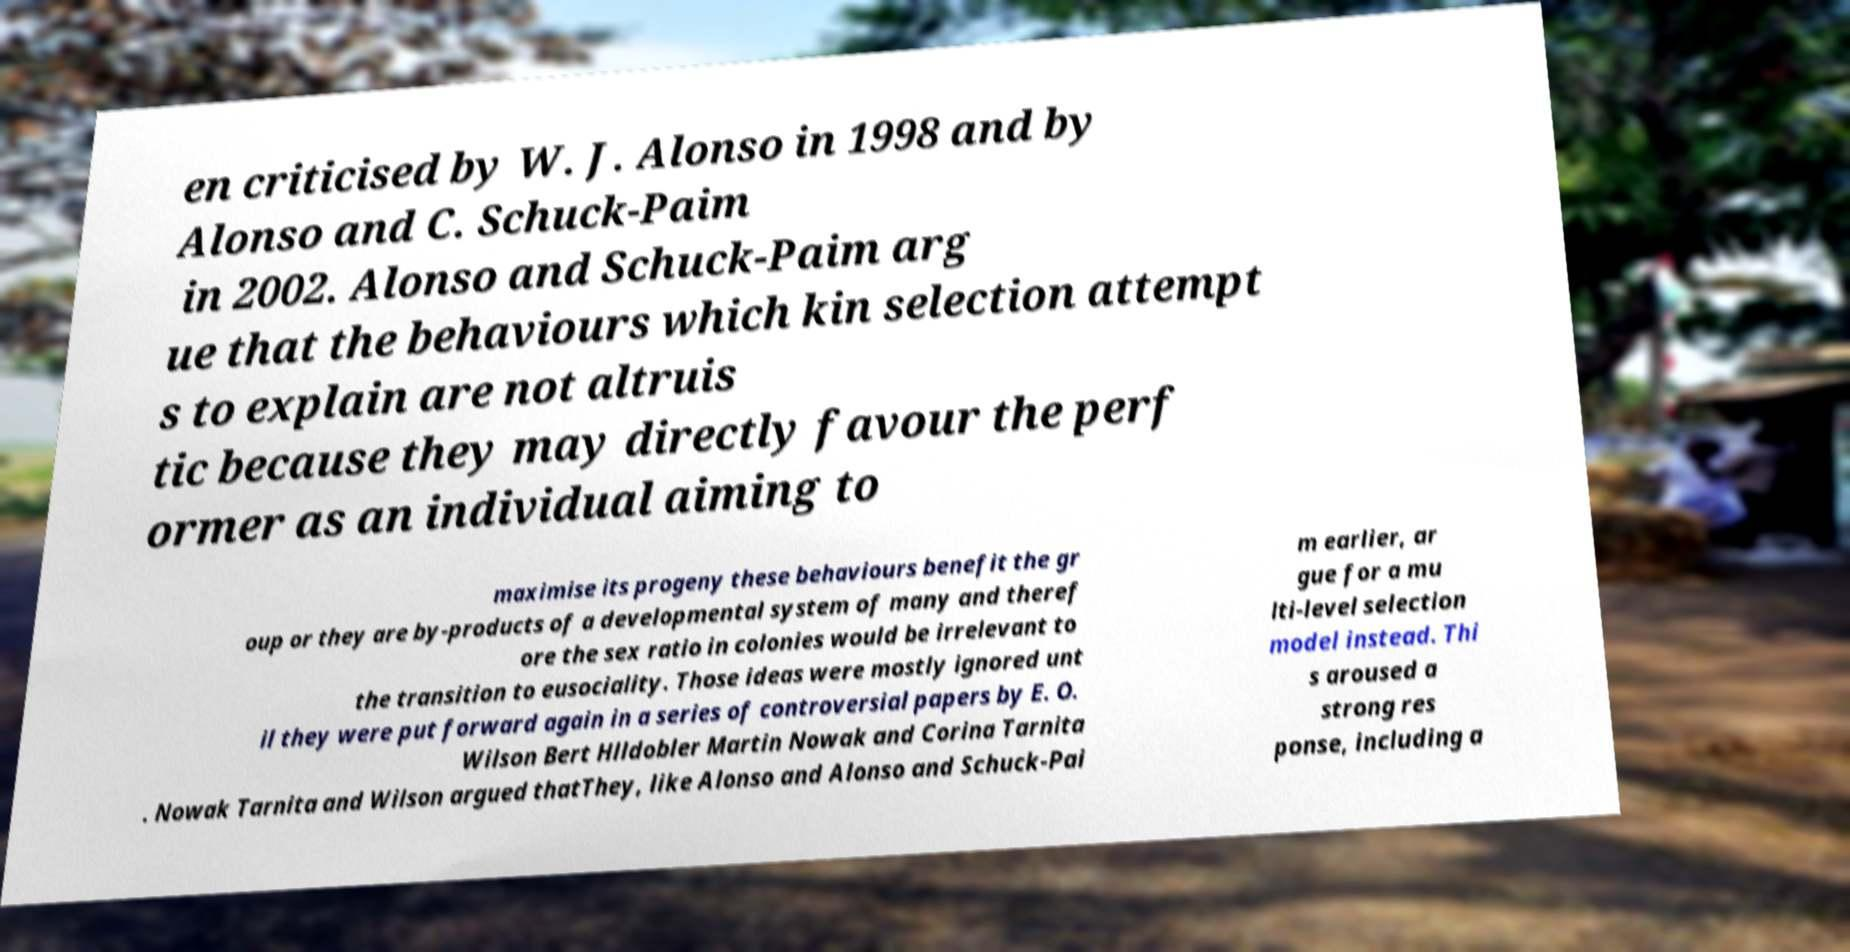What messages or text are displayed in this image? I need them in a readable, typed format. en criticised by W. J. Alonso in 1998 and by Alonso and C. Schuck-Paim in 2002. Alonso and Schuck-Paim arg ue that the behaviours which kin selection attempt s to explain are not altruis tic because they may directly favour the perf ormer as an individual aiming to maximise its progeny these behaviours benefit the gr oup or they are by-products of a developmental system of many and theref ore the sex ratio in colonies would be irrelevant to the transition to eusociality. Those ideas were mostly ignored unt il they were put forward again in a series of controversial papers by E. O. Wilson Bert Hlldobler Martin Nowak and Corina Tarnita . Nowak Tarnita and Wilson argued thatThey, like Alonso and Alonso and Schuck-Pai m earlier, ar gue for a mu lti-level selection model instead. Thi s aroused a strong res ponse, including a 